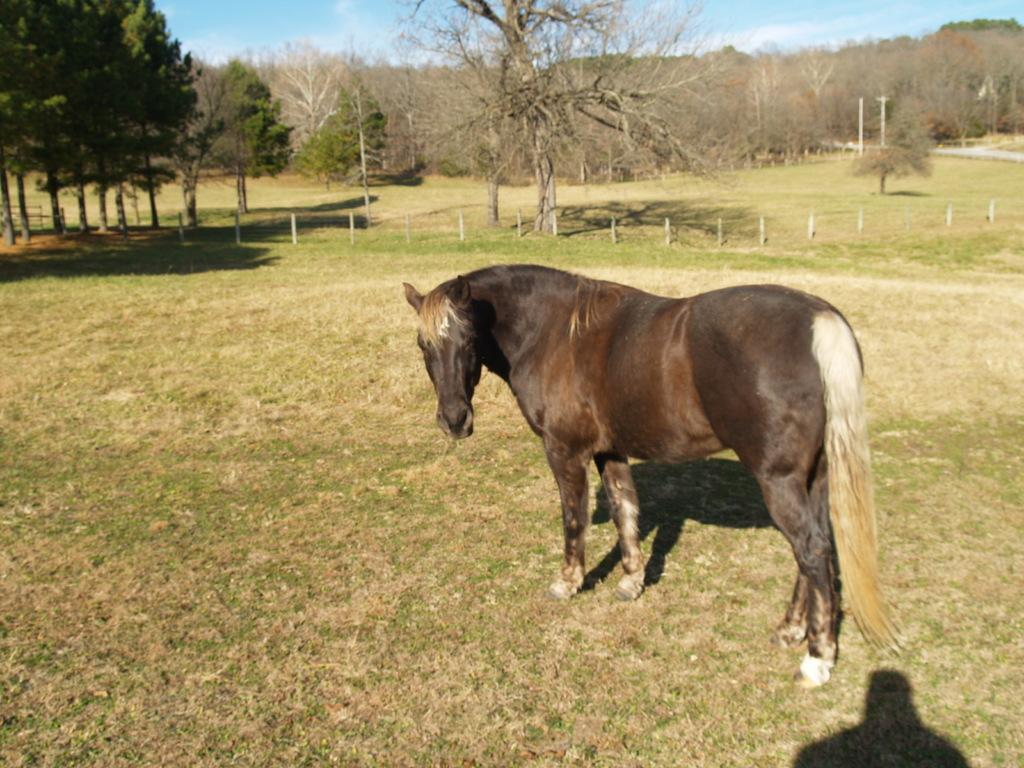Describe this image in one or two sentences. This picture contains a horse which is in black color. At the bottom of the picture, we see grass. In the background, there are many trees and we even see small poles. At the top of the picture, we see the sky. 